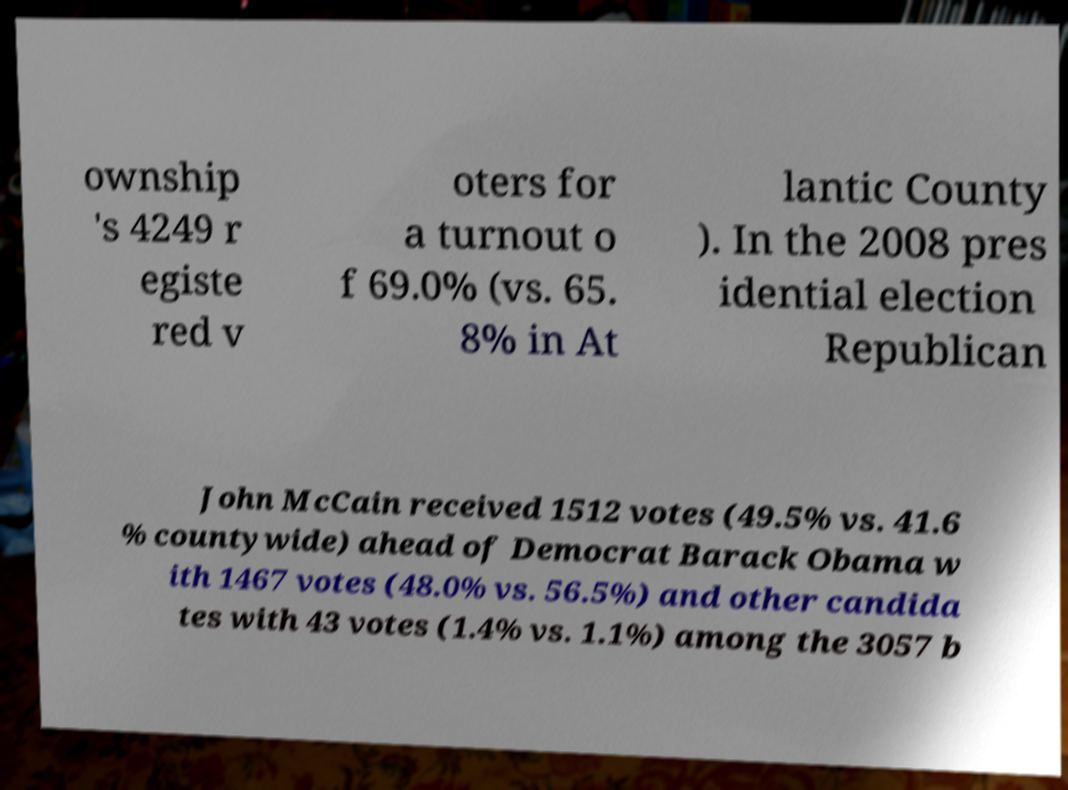Can you accurately transcribe the text from the provided image for me? ownship 's 4249 r egiste red v oters for a turnout o f 69.0% (vs. 65. 8% in At lantic County ). In the 2008 pres idential election Republican John McCain received 1512 votes (49.5% vs. 41.6 % countywide) ahead of Democrat Barack Obama w ith 1467 votes (48.0% vs. 56.5%) and other candida tes with 43 votes (1.4% vs. 1.1%) among the 3057 b 